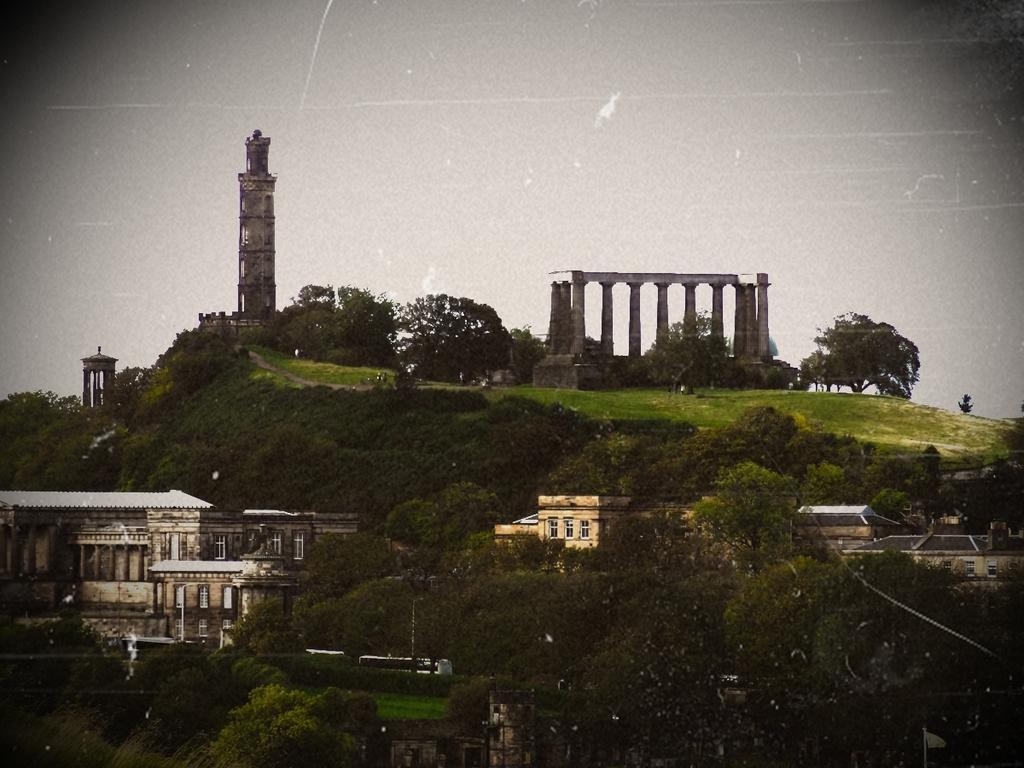Please provide a concise description of this image. In this image we can see a group of buildings with windows, roofs and pillars. On the left side of the image we can see some towers. In the foreground we can see some vehicles and a group of trees. In the background, we can see the sky. 